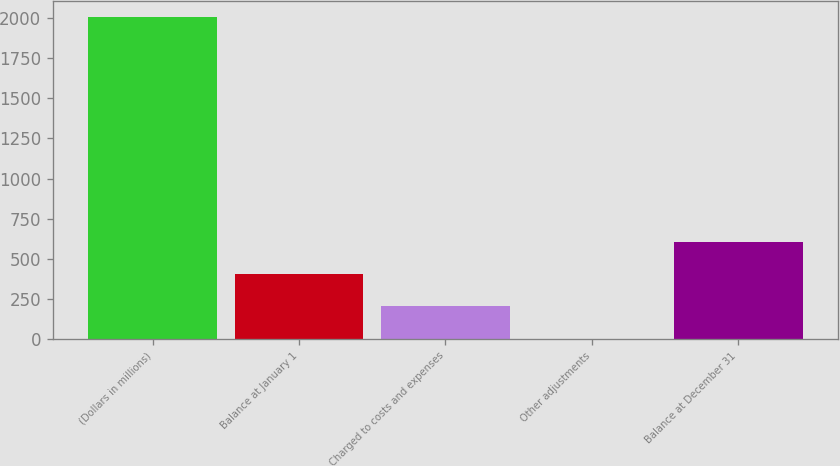Convert chart to OTSL. <chart><loc_0><loc_0><loc_500><loc_500><bar_chart><fcel>(Dollars in millions)<fcel>Balance at January 1<fcel>Charged to costs and expenses<fcel>Other adjustments<fcel>Balance at December 31<nl><fcel>2006<fcel>403.6<fcel>203.3<fcel>3<fcel>603.9<nl></chart> 